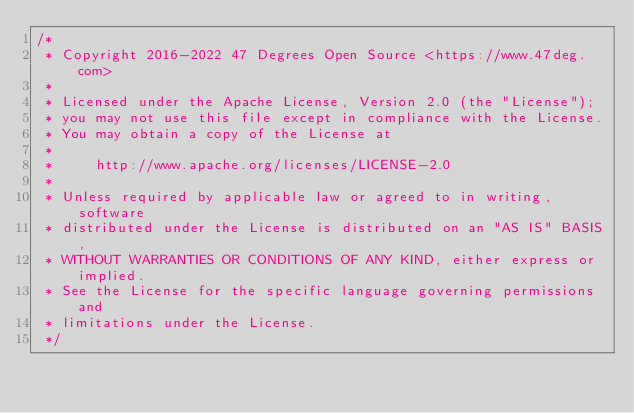<code> <loc_0><loc_0><loc_500><loc_500><_Scala_>/*
 * Copyright 2016-2022 47 Degrees Open Source <https://www.47deg.com>
 *
 * Licensed under the Apache License, Version 2.0 (the "License");
 * you may not use this file except in compliance with the License.
 * You may obtain a copy of the License at
 *
 *     http://www.apache.org/licenses/LICENSE-2.0
 *
 * Unless required by applicable law or agreed to in writing, software
 * distributed under the License is distributed on an "AS IS" BASIS,
 * WITHOUT WARRANTIES OR CONDITIONS OF ANY KIND, either express or implied.
 * See the License for the specific language governing permissions and
 * limitations under the License.
 */
</code> 